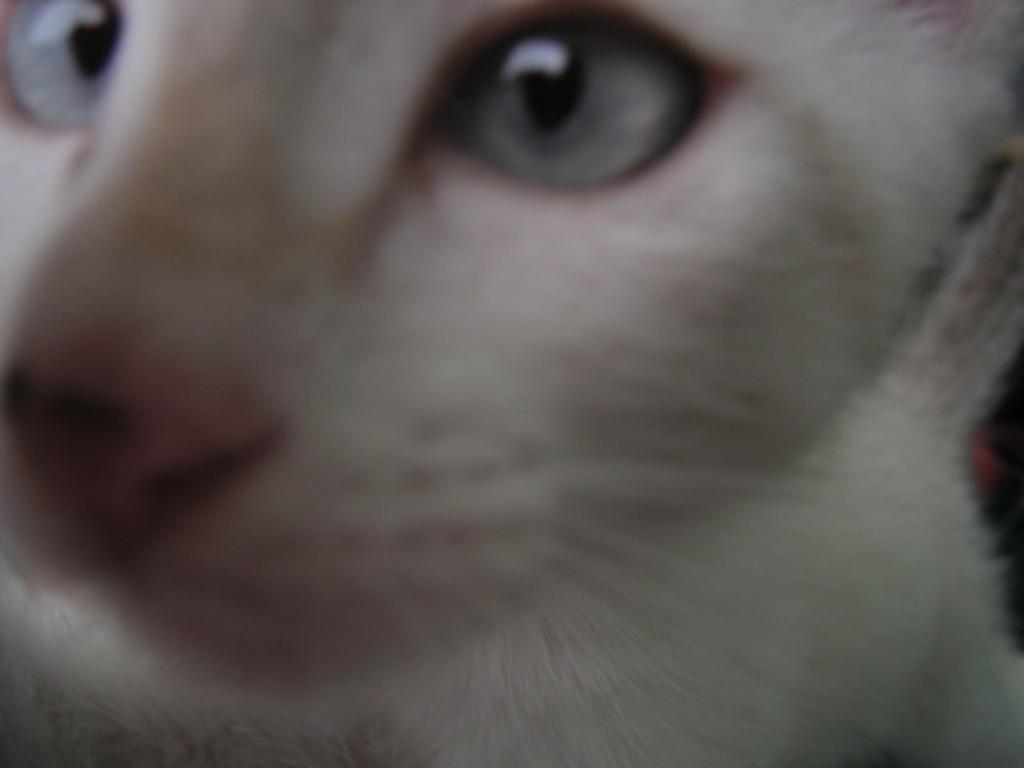What type of animal is in the image? There is a cat in the image. What color is the cat? The cat is white in color. How much money is the cat holding in the image? There is no money present in the image, as it features a white cat. 